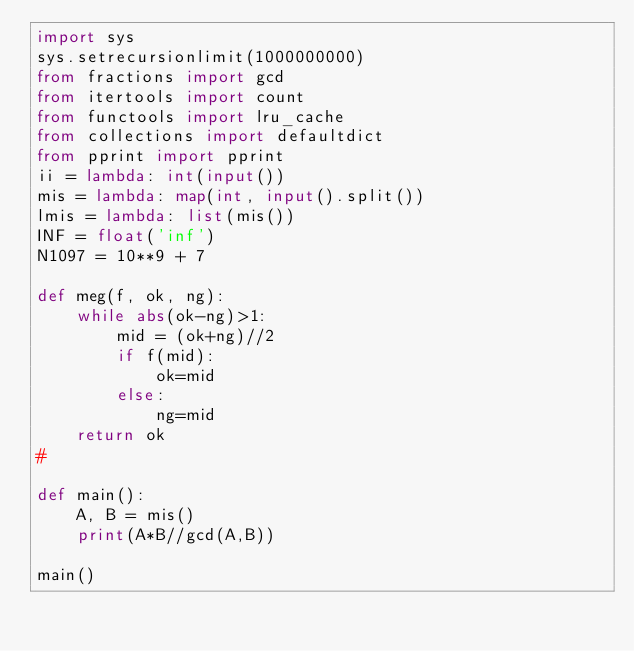Convert code to text. <code><loc_0><loc_0><loc_500><loc_500><_Python_>import sys
sys.setrecursionlimit(1000000000)
from fractions import gcd
from itertools import count
from functools import lru_cache
from collections import defaultdict
from pprint import pprint
ii = lambda: int(input())
mis = lambda: map(int, input().split())
lmis = lambda: list(mis())
INF = float('inf')
N1097 = 10**9 + 7

def meg(f, ok, ng):
    while abs(ok-ng)>1:
        mid = (ok+ng)//2
        if f(mid):
            ok=mid
        else:
            ng=mid
    return ok
#

def main():
    A, B = mis()
    print(A*B//gcd(A,B))

main()
</code> 